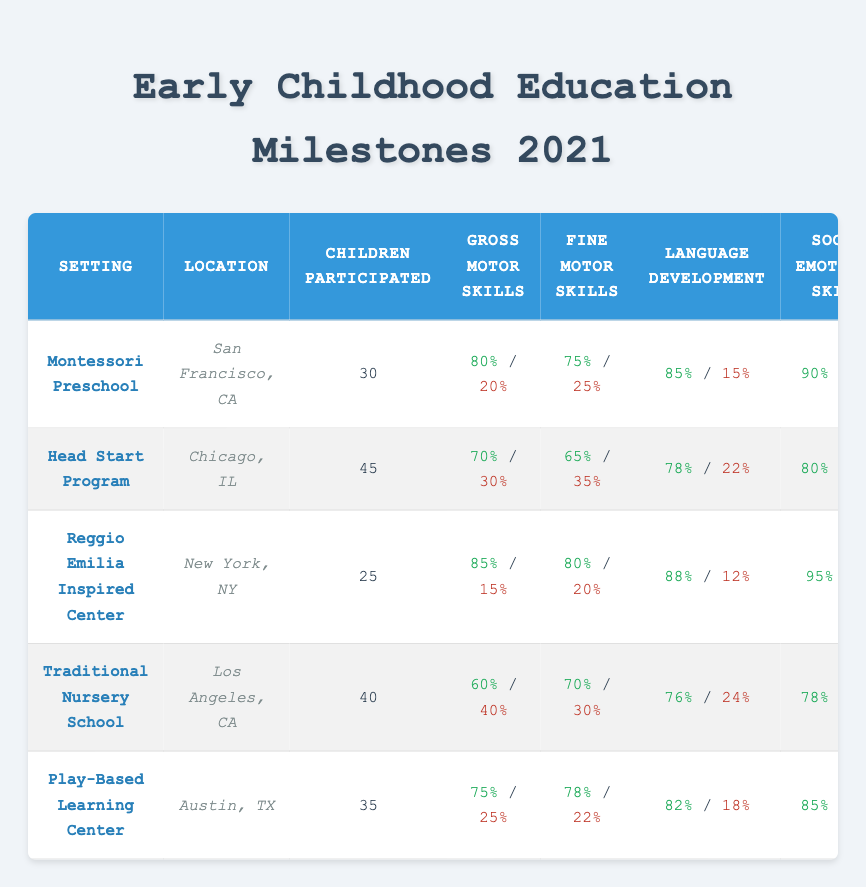What percentage of children achieved gross motor skills in the Montessori Preschool? The table shows that 80% of children achieved gross motor skills in the Montessori Preschool setting.
Answer: 80% How many children participated in the Head Start Program? The table indicates that 45 children participated in the Head Start Program.
Answer: 45 What is the percentage difference in language development achievement between the Reggio Emilia Inspired Center and the Traditional Nursery School? The Reggio Emilia Inspired Center achieved 88% in language development, while the Traditional Nursery School achieved 76%. The difference is 88% - 76% = 12%.
Answer: 12% Did the Play-Based Learning Center achieve a higher percentage of fine motor skills than the Head Start Program? The Play-Based Learning Center achieved 78% in fine motor skills, while the Head Start Program achieved 65%. Since 78% is greater than 65%, the statement is true.
Answer: Yes Which setting had the highest percentage of children achieving social-emotional skills? Looking at the table, the Reggio Emilia Inspired Center had the highest percentage at 95%.
Answer: Reggio Emilia Inspired Center What is the average percentage for gross motor skills achievement across all settings? The percentages for gross motor skills achievement are 80% (Montessori), 70% (Head Start), 85% (Reggio Emilia), 60% (Traditional Nursery), and 75% (Play-Based). To find the average, add the percentages: 80 + 70 + 85 + 60 + 75 = 370, then divide by 5: 370 / 5 = 74%.
Answer: 74% Is it true that all settings achieved at least 60% in fine motor skills? Inspecting the data in the table, all settings have fine motor skills percentages of 75%, 65%, 80%, 70%, and 78%, respectively. Since the lowest value is 65%, this statement is true.
Answer: Yes What percentage of children did not achieve social-emotional skills in the Traditional Nursery School? According to the table, 22% of children in the Traditional Nursery School did not achieve social-emotional skills.
Answer: 22% How many more children participated in the Head Start Program than in the Reggio Emilia Inspired Center? The Head Start Program had 45 participants, and the Reggio Emilia Inspired Center had 25. The difference is 45 - 25 = 20.
Answer: 20 Which location had the lowest rate of achieving gross motor skills out of all listed? Upon examination, the Traditional Nursery School achieved the lowest rate at 60% for gross motor skills.
Answer: Traditional Nursery School What is the ratio of achieved to not achieved gross motor skills in the Play-Based Learning Center? The Play-Based Learning Center had 75% achieved and 25% not achieved for gross motor skills. The ratio is 75:25, which simplifies to 3:1.
Answer: 3:1 